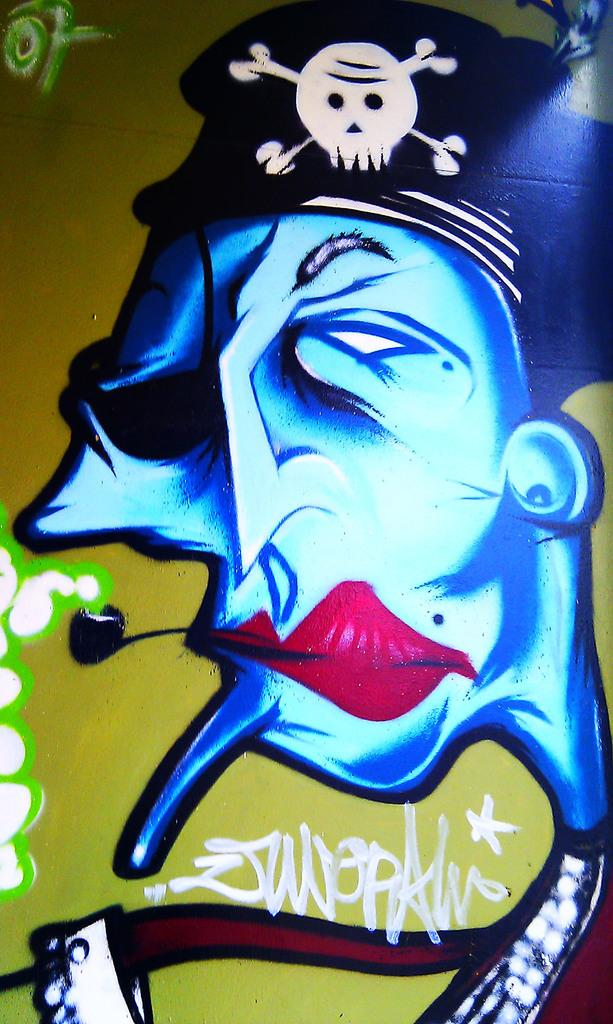What is depicted on the wall in the image? There is a painting on the wall in the image. What does the painting represent? The painting represents a person's face. What is the aftermath of the person's jump in the painting? There is no person jumping in the painting, as it represents a person's face. 